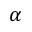Convert formula to latex. <formula><loc_0><loc_0><loc_500><loc_500>\alpha</formula> 